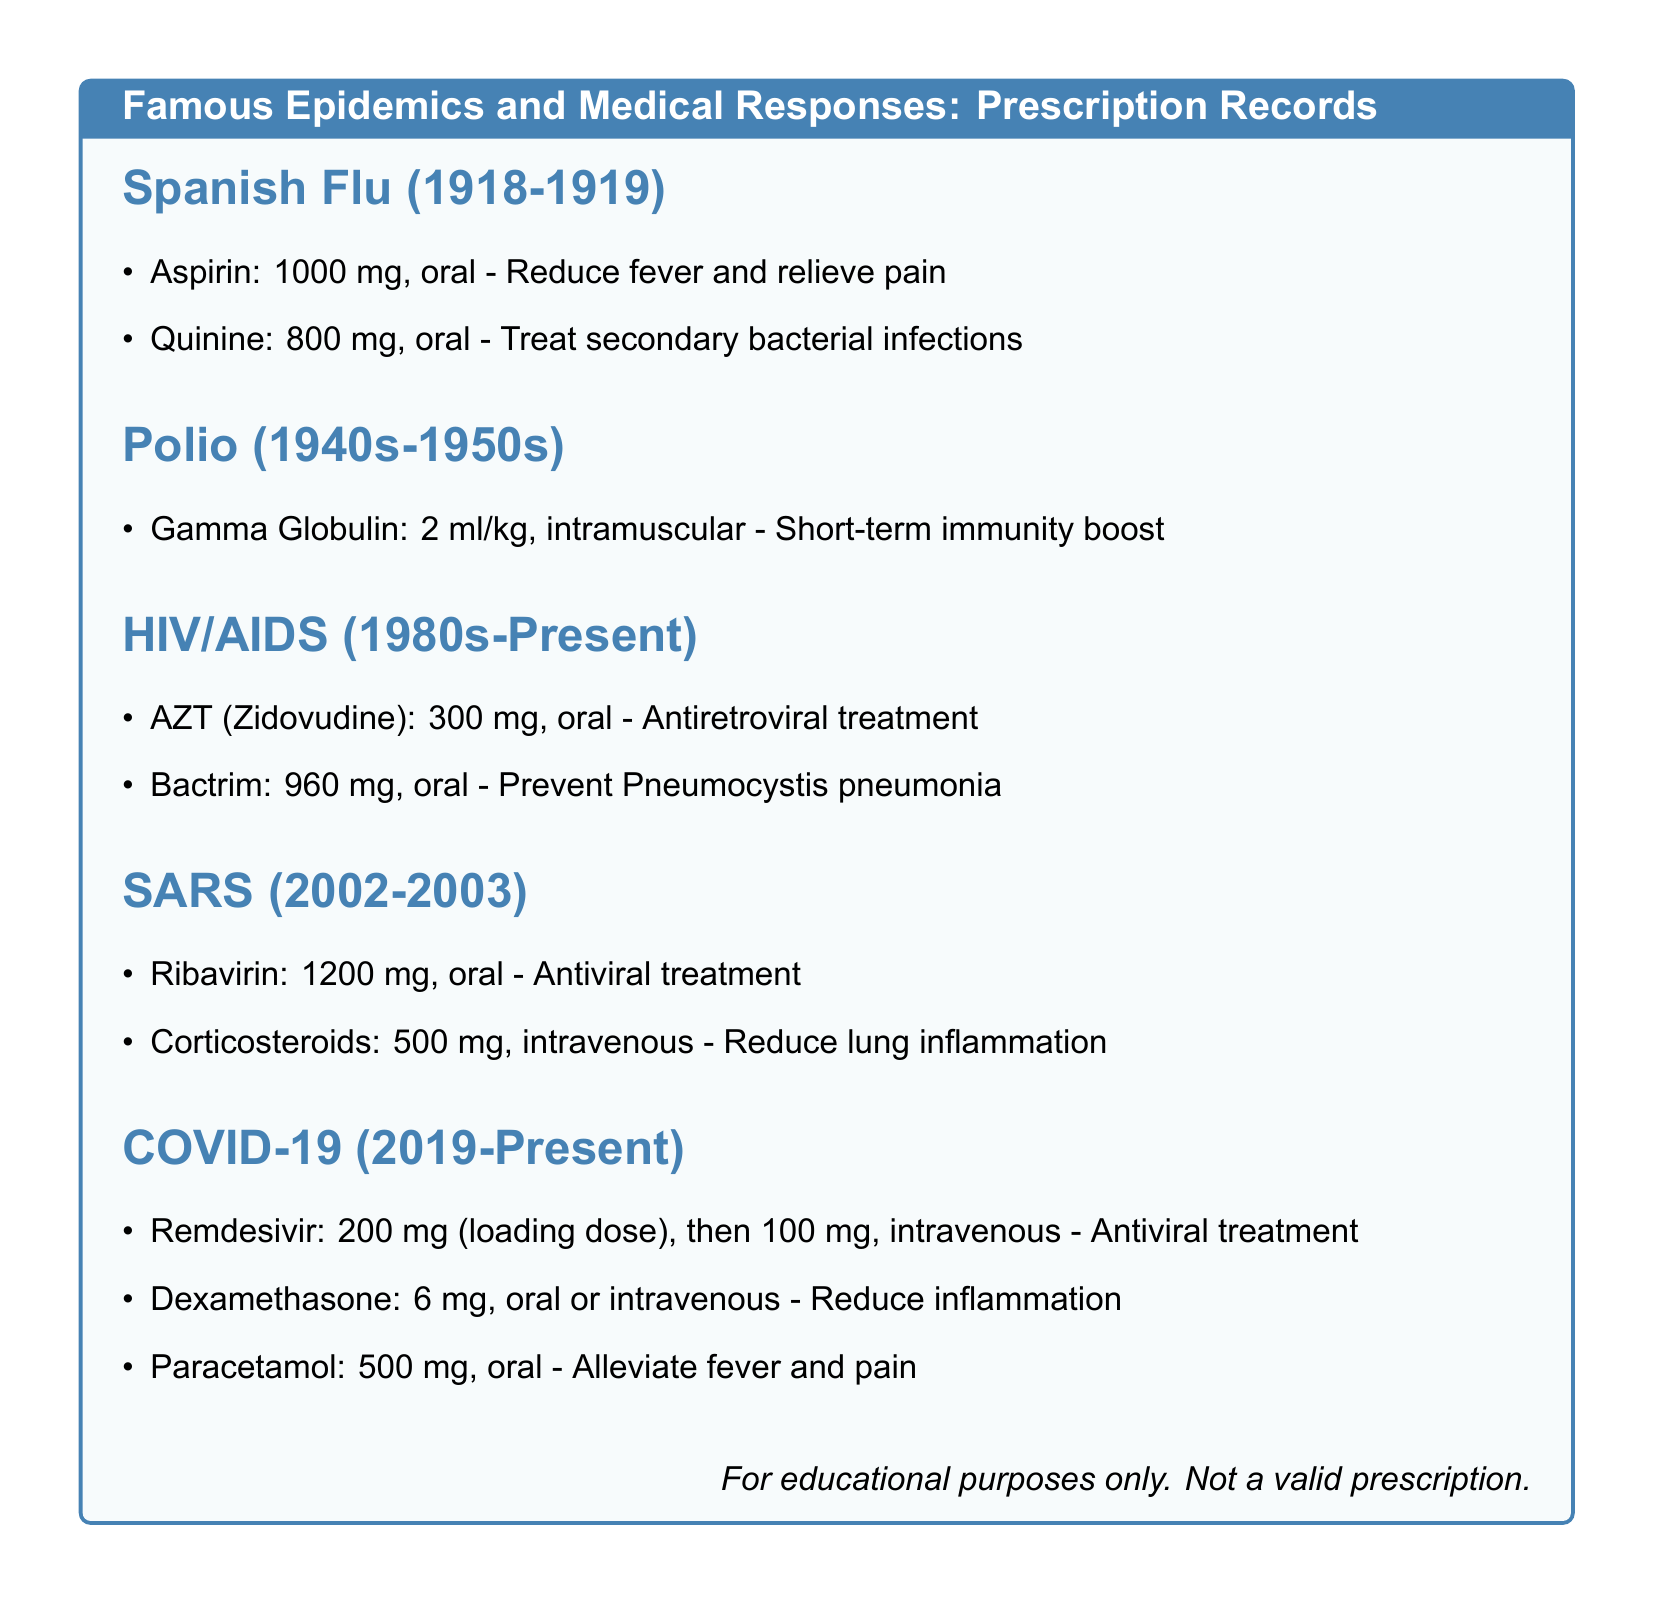What are the drugs prescribed for Spanish Flu? The document lists Aspirin and Quinine as the drugs prescribed for Spanish Flu.
Answer: Aspirin, Quinine What is the prescribed dosage of AZT for HIV/AIDS? The document specifies the dosage of AZT (Zidovudine) as 300 mg.
Answer: 300 mg What is the administration route for Ribavirin during the SARS outbreak? The document states that Ribavirin is administered orally.
Answer: oral What is the primary purpose of Dexamethasone in COVID-19 treatment? The document indicates that Dexamethasone is used to reduce inflammation.
Answer: Reduce inflammation How many milligrams of Quinine are prescribed for the Spanish Flu? The document specifies that 800 mg of Quinine is prescribed.
Answer: 800 mg Which drug is listed for preventing Pneumocystis pneumonia in HIV/AIDS? The document mentions Bactrim as the drug for preventing Pneumocystis pneumonia.
Answer: Bactrim What route of administration is used for Gamma Globulin in Polio treatment? The document states that Gamma Globulin is administered intramuscularly.
Answer: intramuscular What loading dose of Remdesivir is prescribed for COVID-19? The document specifies a loading dose of 200 mg for Remdesivir.
Answer: 200 mg What type of document is this? The document is a record of prescriptions issued during major disease outbreaks.
Answer: Prescription Records 